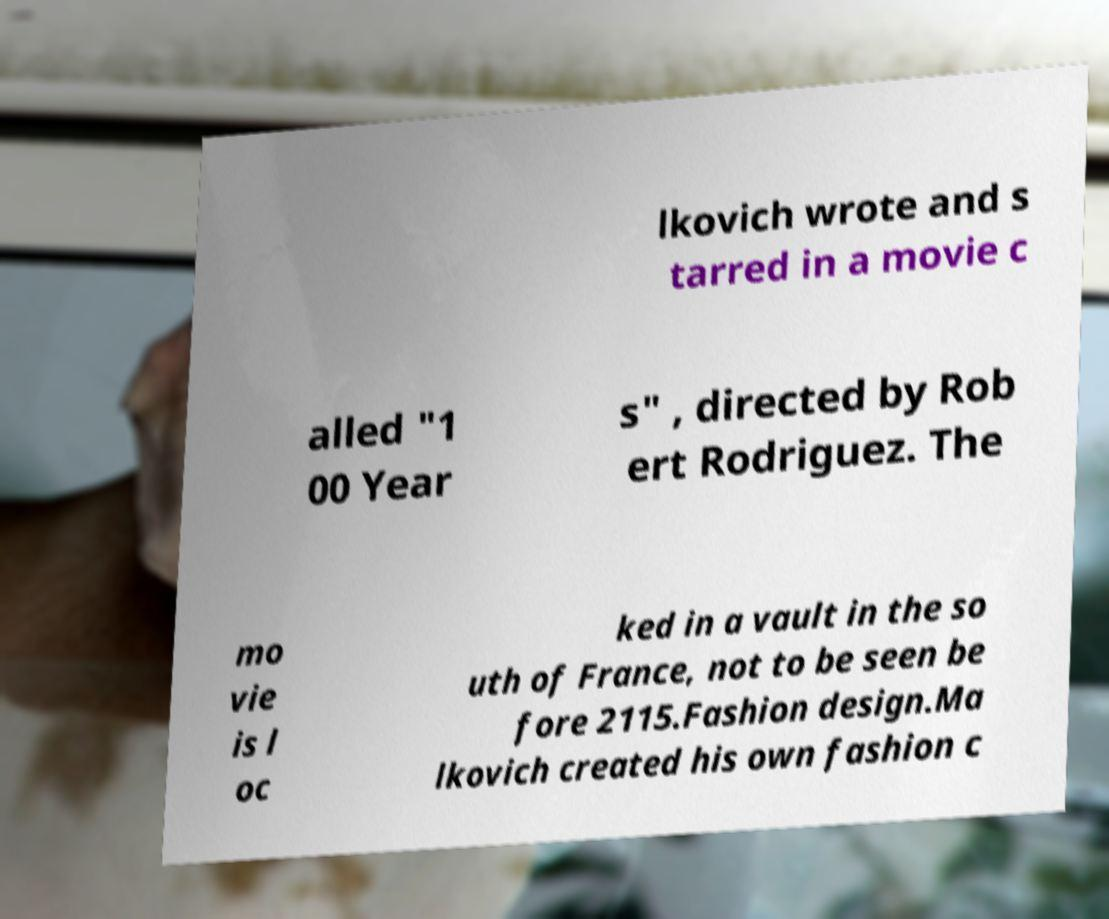Can you accurately transcribe the text from the provided image for me? lkovich wrote and s tarred in a movie c alled "1 00 Year s" , directed by Rob ert Rodriguez. The mo vie is l oc ked in a vault in the so uth of France, not to be seen be fore 2115.Fashion design.Ma lkovich created his own fashion c 